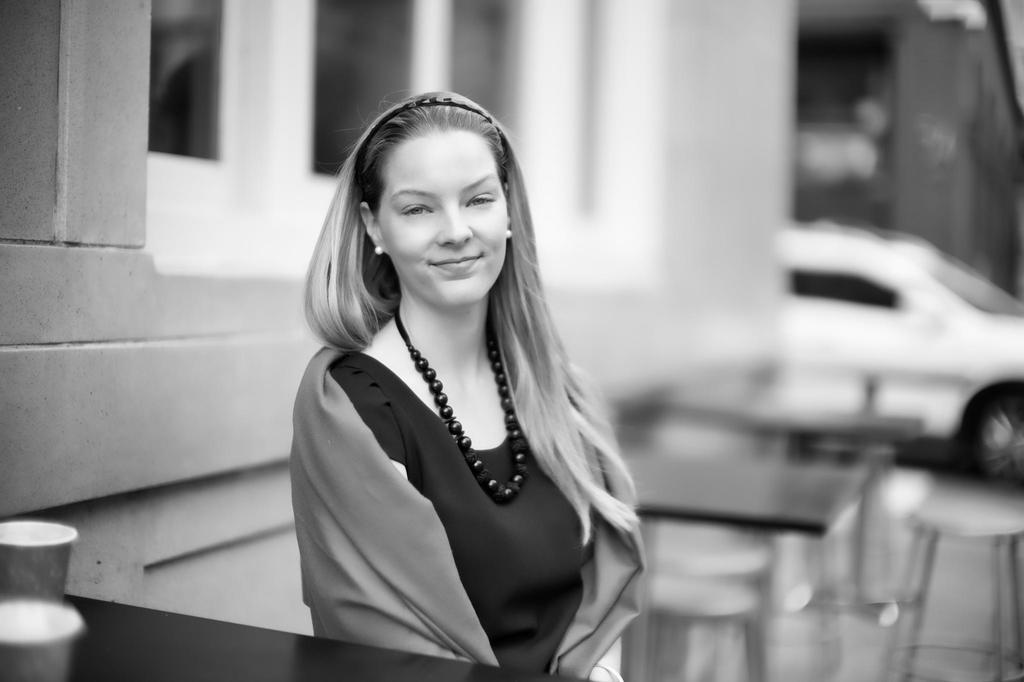Who is present in the image? There is a woman in the image. What type of furniture can be seen in the image? There are stools and tables in the image. What can be seen in the background of the image? There are buildings in the background of the image. What mode of transportation is visible in the image? There is a car in the image. What type of jelly is being used to power the apparatus in the image? There is no jelly or apparatus present in the image. 